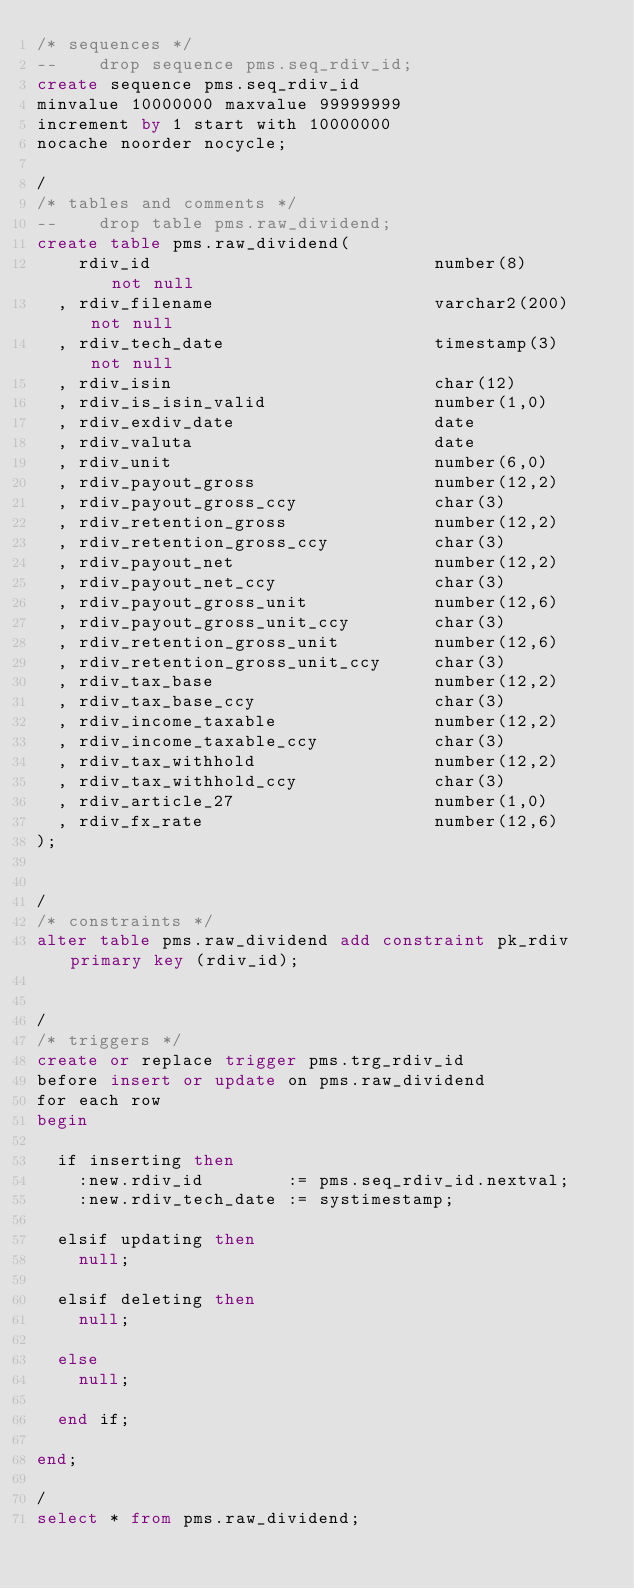Convert code to text. <code><loc_0><loc_0><loc_500><loc_500><_SQL_>/* sequences */
--    drop sequence pms.seq_rdiv_id;
create sequence pms.seq_rdiv_id
minvalue 10000000 maxvalue 99999999
increment by 1 start with 10000000
nocache noorder nocycle;

/
/* tables and comments */
--    drop table pms.raw_dividend;
create table pms.raw_dividend(
    rdiv_id                           number(8)       not null
  , rdiv_filename                     varchar2(200)   not null
  , rdiv_tech_date                    timestamp(3)    not null
  , rdiv_isin                         char(12)
  , rdiv_is_isin_valid                number(1,0)
  , rdiv_exdiv_date                   date
  , rdiv_valuta                       date
  , rdiv_unit                         number(6,0)
  , rdiv_payout_gross                 number(12,2)
  , rdiv_payout_gross_ccy             char(3)
  , rdiv_retention_gross              number(12,2)
  , rdiv_retention_gross_ccy          char(3)
  , rdiv_payout_net                   number(12,2)
  , rdiv_payout_net_ccy               char(3)
  , rdiv_payout_gross_unit            number(12,6)
  , rdiv_payout_gross_unit_ccy        char(3)
  , rdiv_retention_gross_unit         number(12,6)
  , rdiv_retention_gross_unit_ccy     char(3)
  , rdiv_tax_base                     number(12,2)
  , rdiv_tax_base_ccy                 char(3)
  , rdiv_income_taxable               number(12,2)
  , rdiv_income_taxable_ccy           char(3)
  , rdiv_tax_withhold                 number(12,2)
  , rdiv_tax_withhold_ccy             char(3)
  , rdiv_article_27                   number(1,0)
  , rdiv_fx_rate                      number(12,6)
);


/
/* constraints */
alter table pms.raw_dividend add constraint pk_rdiv primary key (rdiv_id);


/
/* triggers */
create or replace trigger pms.trg_rdiv_id
before insert or update on pms.raw_dividend
for each row
begin
  
  if inserting then
    :new.rdiv_id        := pms.seq_rdiv_id.nextval;
    :new.rdiv_tech_date := systimestamp;
    
  elsif updating then
    null;
  
  elsif deleting then
    null;
  
  else
    null;
  
  end if;
  
end;

/
select * from pms.raw_dividend;
</code> 